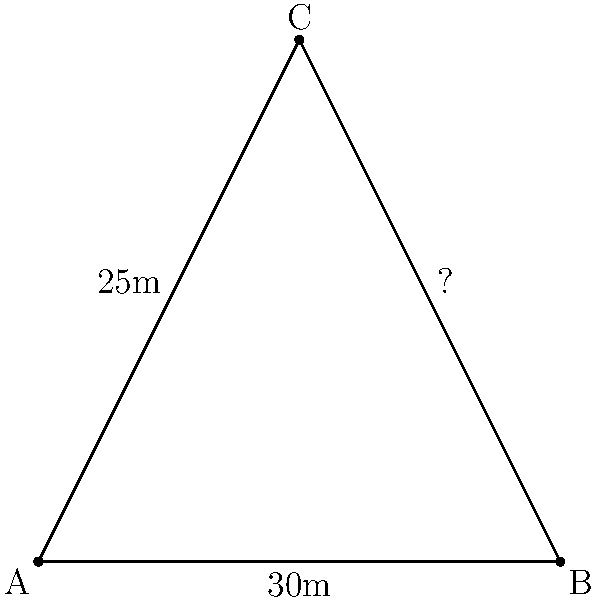In the aerial view of a triangular playing field shown above, players A, B, and C are positioned at the vertices. The distance between A and B is 30 meters, and the distance between A and C is 25 meters. Estimate the distance between players B and C to the nearest meter. To estimate the distance between players B and C, we can use the properties of triangles:

1. Recognize that this forms a triangle with known sides AB and AC.
2. The triangle appears to be roughly right-angled at A, but not exactly.
3. If it were a right triangle, we could use the Pythagorean theorem: $BC^2 = AB^2 + AC^2$
4. $AB^2 = 30^2 = 900$
5. $AC^2 = 25^2 = 625$
6. $BC^2 \approx 900 + 625 = 1525$
7. $BC \approx \sqrt{1525} \approx 39.05$

However, since the triangle is not exactly right-angled, the actual distance will be slightly less than this calculation.

8. Estimating visually, the angle at A appears to be slightly larger than 90°.
9. This would make the distance BC slightly shorter than our calculation.

Therefore, a reasonable estimate for BC would be about 38 meters.
Answer: 38 meters 